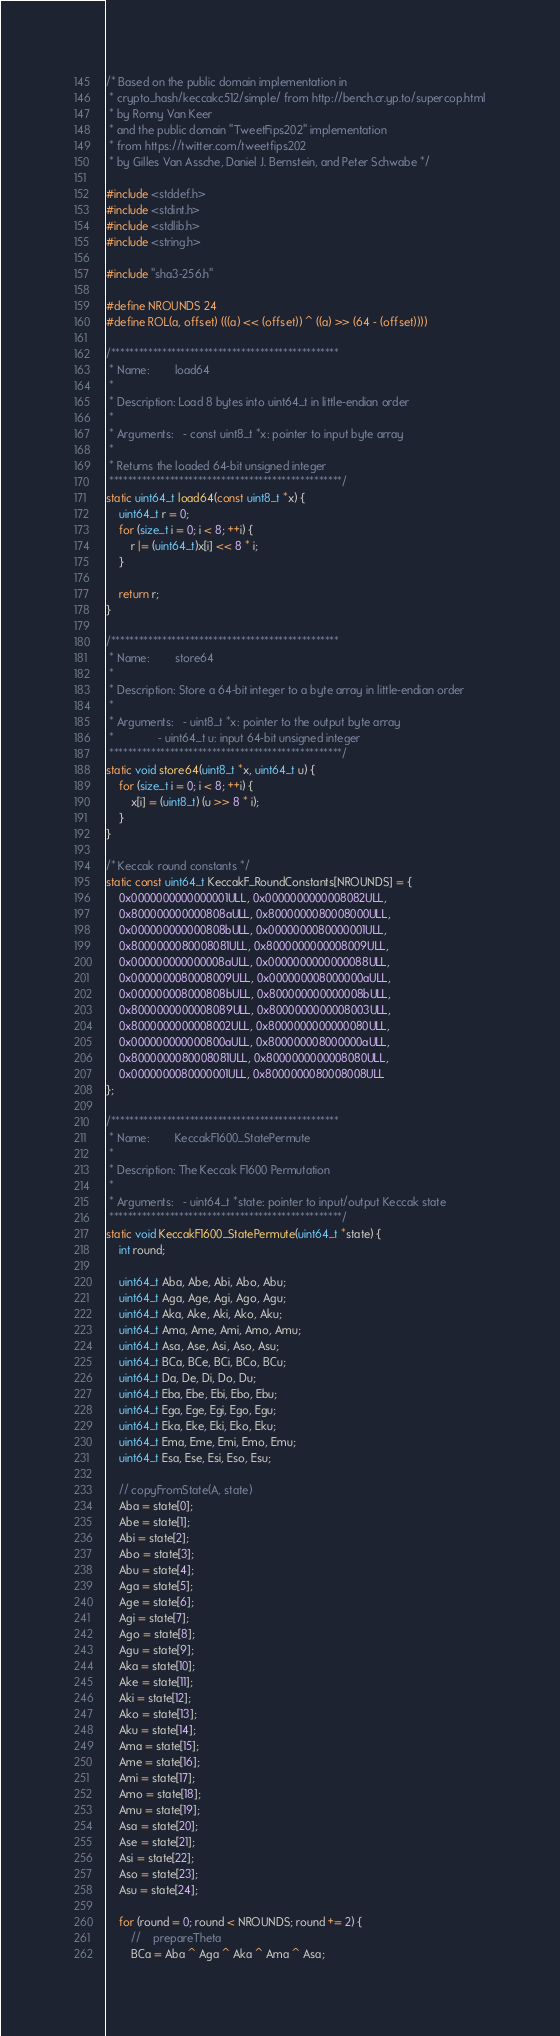<code> <loc_0><loc_0><loc_500><loc_500><_C_>/* Based on the public domain implementation in
 * crypto_hash/keccakc512/simple/ from http://bench.cr.yp.to/supercop.html
 * by Ronny Van Keer
 * and the public domain "TweetFips202" implementation
 * from https://twitter.com/tweetfips202
 * by Gilles Van Assche, Daniel J. Bernstein, and Peter Schwabe */

#include <stddef.h>
#include <stdint.h>
#include <stdlib.h>
#include <string.h>

#include "sha3-256.h"

#define NROUNDS 24
#define ROL(a, offset) (((a) << (offset)) ^ ((a) >> (64 - (offset))))

/*************************************************
 * Name:        load64
 *
 * Description: Load 8 bytes into uint64_t in little-endian order
 *
 * Arguments:   - const uint8_t *x: pointer to input byte array
 *
 * Returns the loaded 64-bit unsigned integer
 **************************************************/
static uint64_t load64(const uint8_t *x) {
    uint64_t r = 0;
    for (size_t i = 0; i < 8; ++i) {
        r |= (uint64_t)x[i] << 8 * i;
    }

    return r;
}

/*************************************************
 * Name:        store64
 *
 * Description: Store a 64-bit integer to a byte array in little-endian order
 *
 * Arguments:   - uint8_t *x: pointer to the output byte array
 *              - uint64_t u: input 64-bit unsigned integer
 **************************************************/
static void store64(uint8_t *x, uint64_t u) {
    for (size_t i = 0; i < 8; ++i) {
        x[i] = (uint8_t) (u >> 8 * i);
    }
}

/* Keccak round constants */
static const uint64_t KeccakF_RoundConstants[NROUNDS] = {
    0x0000000000000001ULL, 0x0000000000008082ULL,
    0x800000000000808aULL, 0x8000000080008000ULL,
    0x000000000000808bULL, 0x0000000080000001ULL,
    0x8000000080008081ULL, 0x8000000000008009ULL,
    0x000000000000008aULL, 0x0000000000000088ULL,
    0x0000000080008009ULL, 0x000000008000000aULL,
    0x000000008000808bULL, 0x800000000000008bULL,
    0x8000000000008089ULL, 0x8000000000008003ULL,
    0x8000000000008002ULL, 0x8000000000000080ULL,
    0x000000000000800aULL, 0x800000008000000aULL,
    0x8000000080008081ULL, 0x8000000000008080ULL,
    0x0000000080000001ULL, 0x8000000080008008ULL
};

/*************************************************
 * Name:        KeccakF1600_StatePermute
 *
 * Description: The Keccak F1600 Permutation
 *
 * Arguments:   - uint64_t *state: pointer to input/output Keccak state
 **************************************************/
static void KeccakF1600_StatePermute(uint64_t *state) {
    int round;

    uint64_t Aba, Abe, Abi, Abo, Abu;
    uint64_t Aga, Age, Agi, Ago, Agu;
    uint64_t Aka, Ake, Aki, Ako, Aku;
    uint64_t Ama, Ame, Ami, Amo, Amu;
    uint64_t Asa, Ase, Asi, Aso, Asu;
    uint64_t BCa, BCe, BCi, BCo, BCu;
    uint64_t Da, De, Di, Do, Du;
    uint64_t Eba, Ebe, Ebi, Ebo, Ebu;
    uint64_t Ega, Ege, Egi, Ego, Egu;
    uint64_t Eka, Eke, Eki, Eko, Eku;
    uint64_t Ema, Eme, Emi, Emo, Emu;
    uint64_t Esa, Ese, Esi, Eso, Esu;

    // copyFromState(A, state)
    Aba = state[0];
    Abe = state[1];
    Abi = state[2];
    Abo = state[3];
    Abu = state[4];
    Aga = state[5];
    Age = state[6];
    Agi = state[7];
    Ago = state[8];
    Agu = state[9];
    Aka = state[10];
    Ake = state[11];
    Aki = state[12];
    Ako = state[13];
    Aku = state[14];
    Ama = state[15];
    Ame = state[16];
    Ami = state[17];
    Amo = state[18];
    Amu = state[19];
    Asa = state[20];
    Ase = state[21];
    Asi = state[22];
    Aso = state[23];
    Asu = state[24];

    for (round = 0; round < NROUNDS; round += 2) {
        //    prepareTheta
        BCa = Aba ^ Aga ^ Aka ^ Ama ^ Asa;</code> 